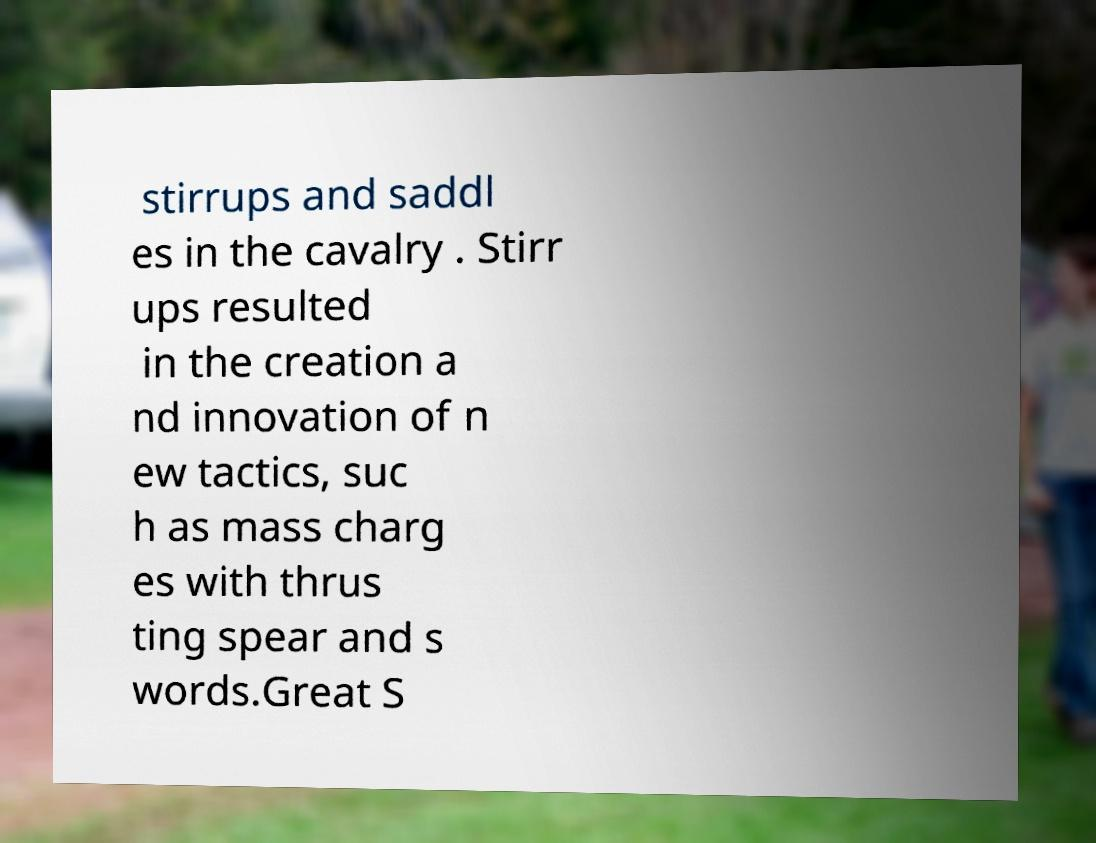For documentation purposes, I need the text within this image transcribed. Could you provide that? stirrups and saddl es in the cavalry . Stirr ups resulted in the creation a nd innovation of n ew tactics, suc h as mass charg es with thrus ting spear and s words.Great S 